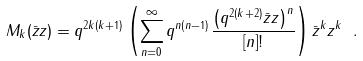<formula> <loc_0><loc_0><loc_500><loc_500>M _ { k } ( \bar { z } z ) = q ^ { 2 k ( k + 1 ) } \left ( \sum ^ { \infty } _ { n = 0 } q ^ { n ( n - 1 ) } \frac { \left ( q ^ { 2 ( k + 2 ) } \bar { z } z \right ) ^ { n } } { [ n ] ! } \right ) \bar { z } ^ { k } z ^ { k } \ .</formula> 